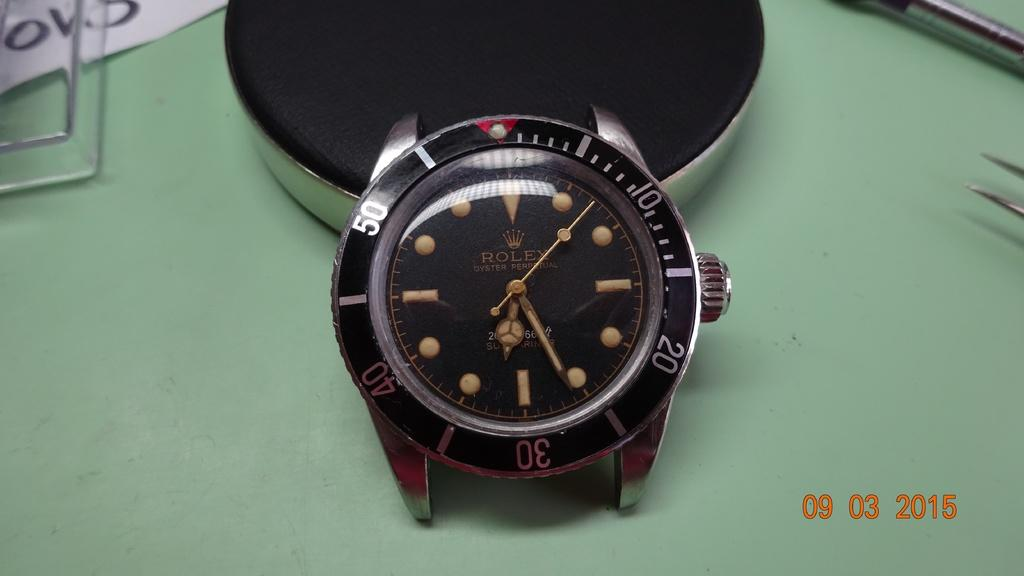<image>
Give a short and clear explanation of the subsequent image. A watch with no band is displayed with the date on the photo being 09 03 2015. 